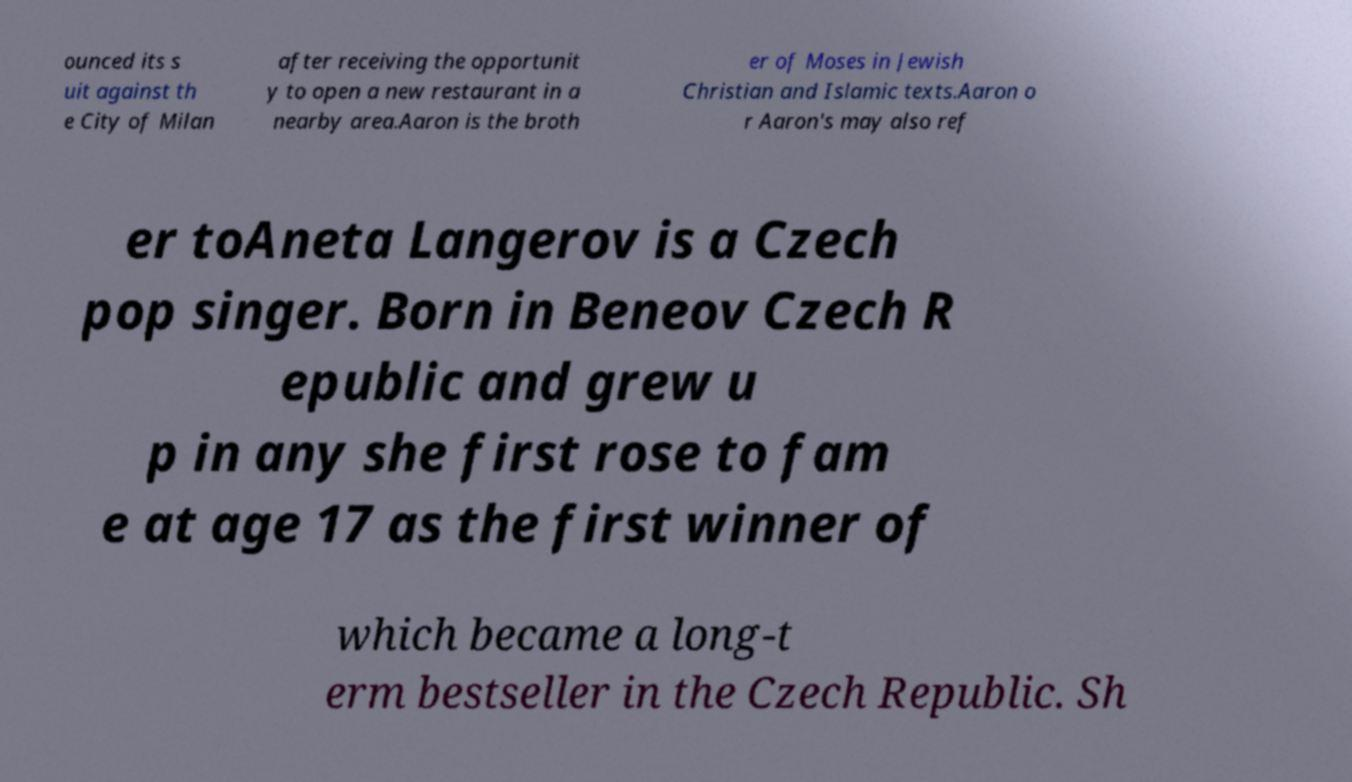What messages or text are displayed in this image? I need them in a readable, typed format. ounced its s uit against th e City of Milan after receiving the opportunit y to open a new restaurant in a nearby area.Aaron is the broth er of Moses in Jewish Christian and Islamic texts.Aaron o r Aaron's may also ref er toAneta Langerov is a Czech pop singer. Born in Beneov Czech R epublic and grew u p in any she first rose to fam e at age 17 as the first winner of which became a long-t erm bestseller in the Czech Republic. Sh 